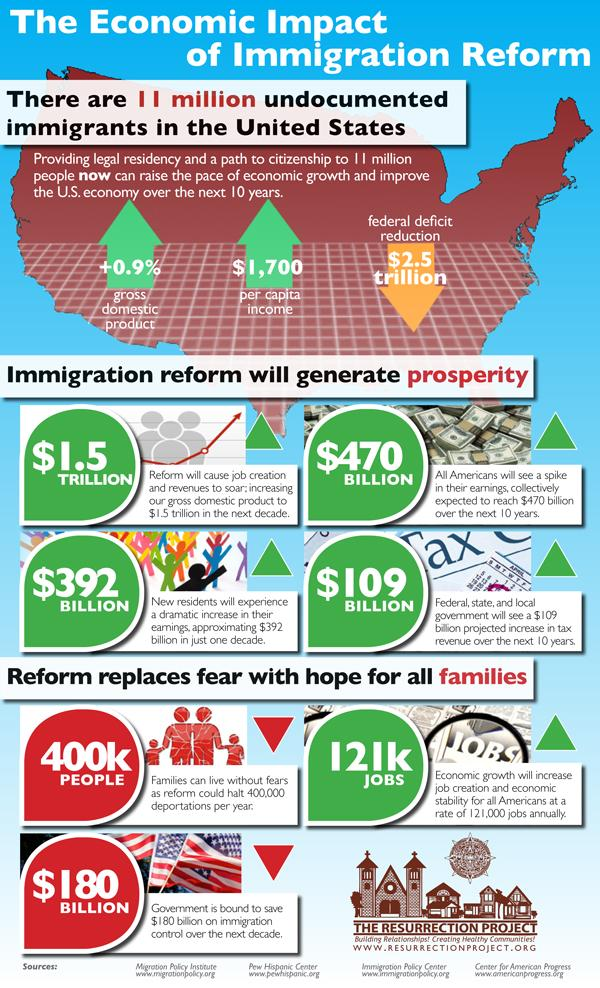Give some essential details in this illustration. The predicted increase in earnings over the next 10 years is 392 billion dollars. 